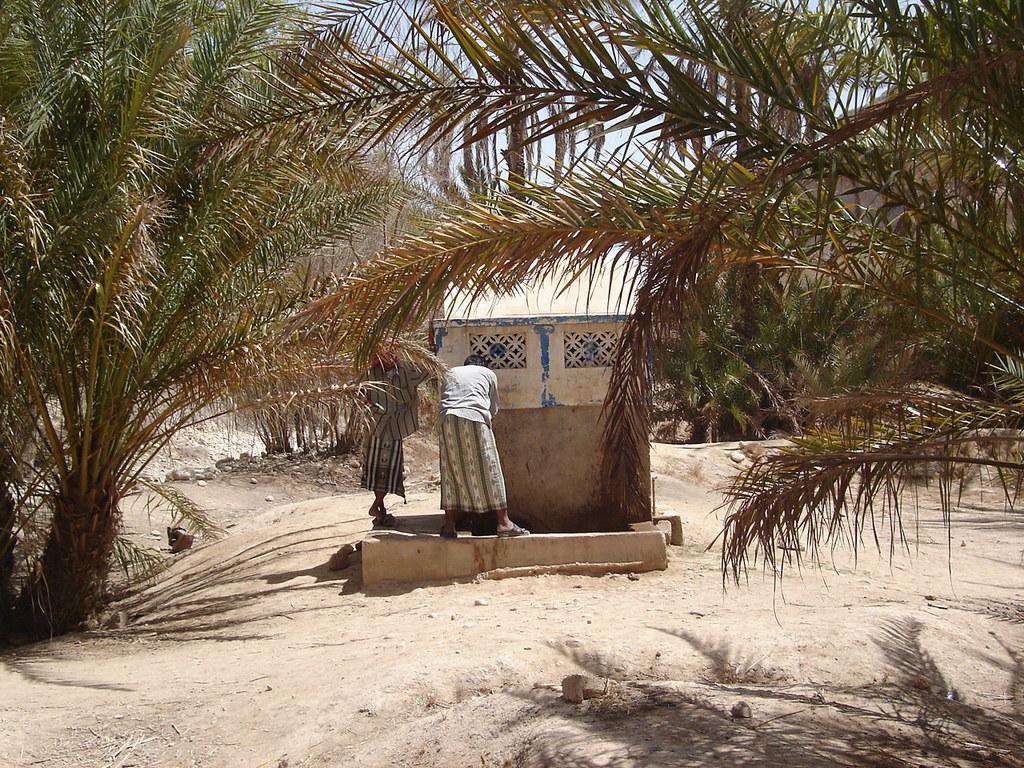Describe this image in one or two sentences. Two people are standing, there are trees and this is mud ground. 